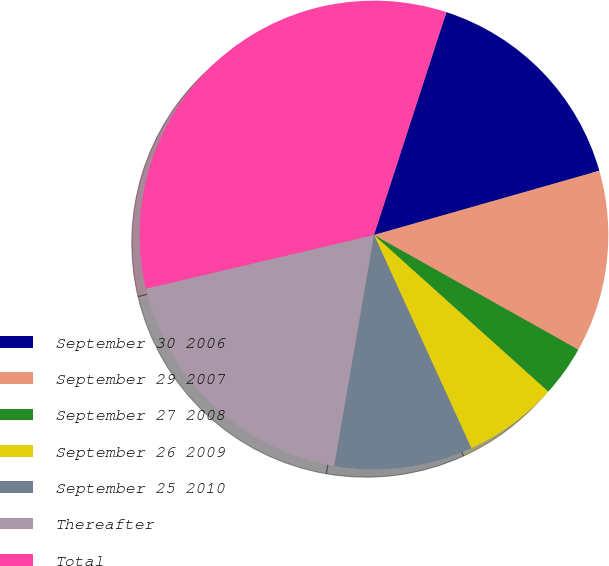Convert chart. <chart><loc_0><loc_0><loc_500><loc_500><pie_chart><fcel>September 30 2006<fcel>September 29 2007<fcel>September 27 2008<fcel>September 26 2009<fcel>September 25 2010<fcel>Thereafter<fcel>Total<nl><fcel>15.58%<fcel>12.56%<fcel>3.51%<fcel>6.53%<fcel>9.54%<fcel>18.6%<fcel>33.68%<nl></chart> 